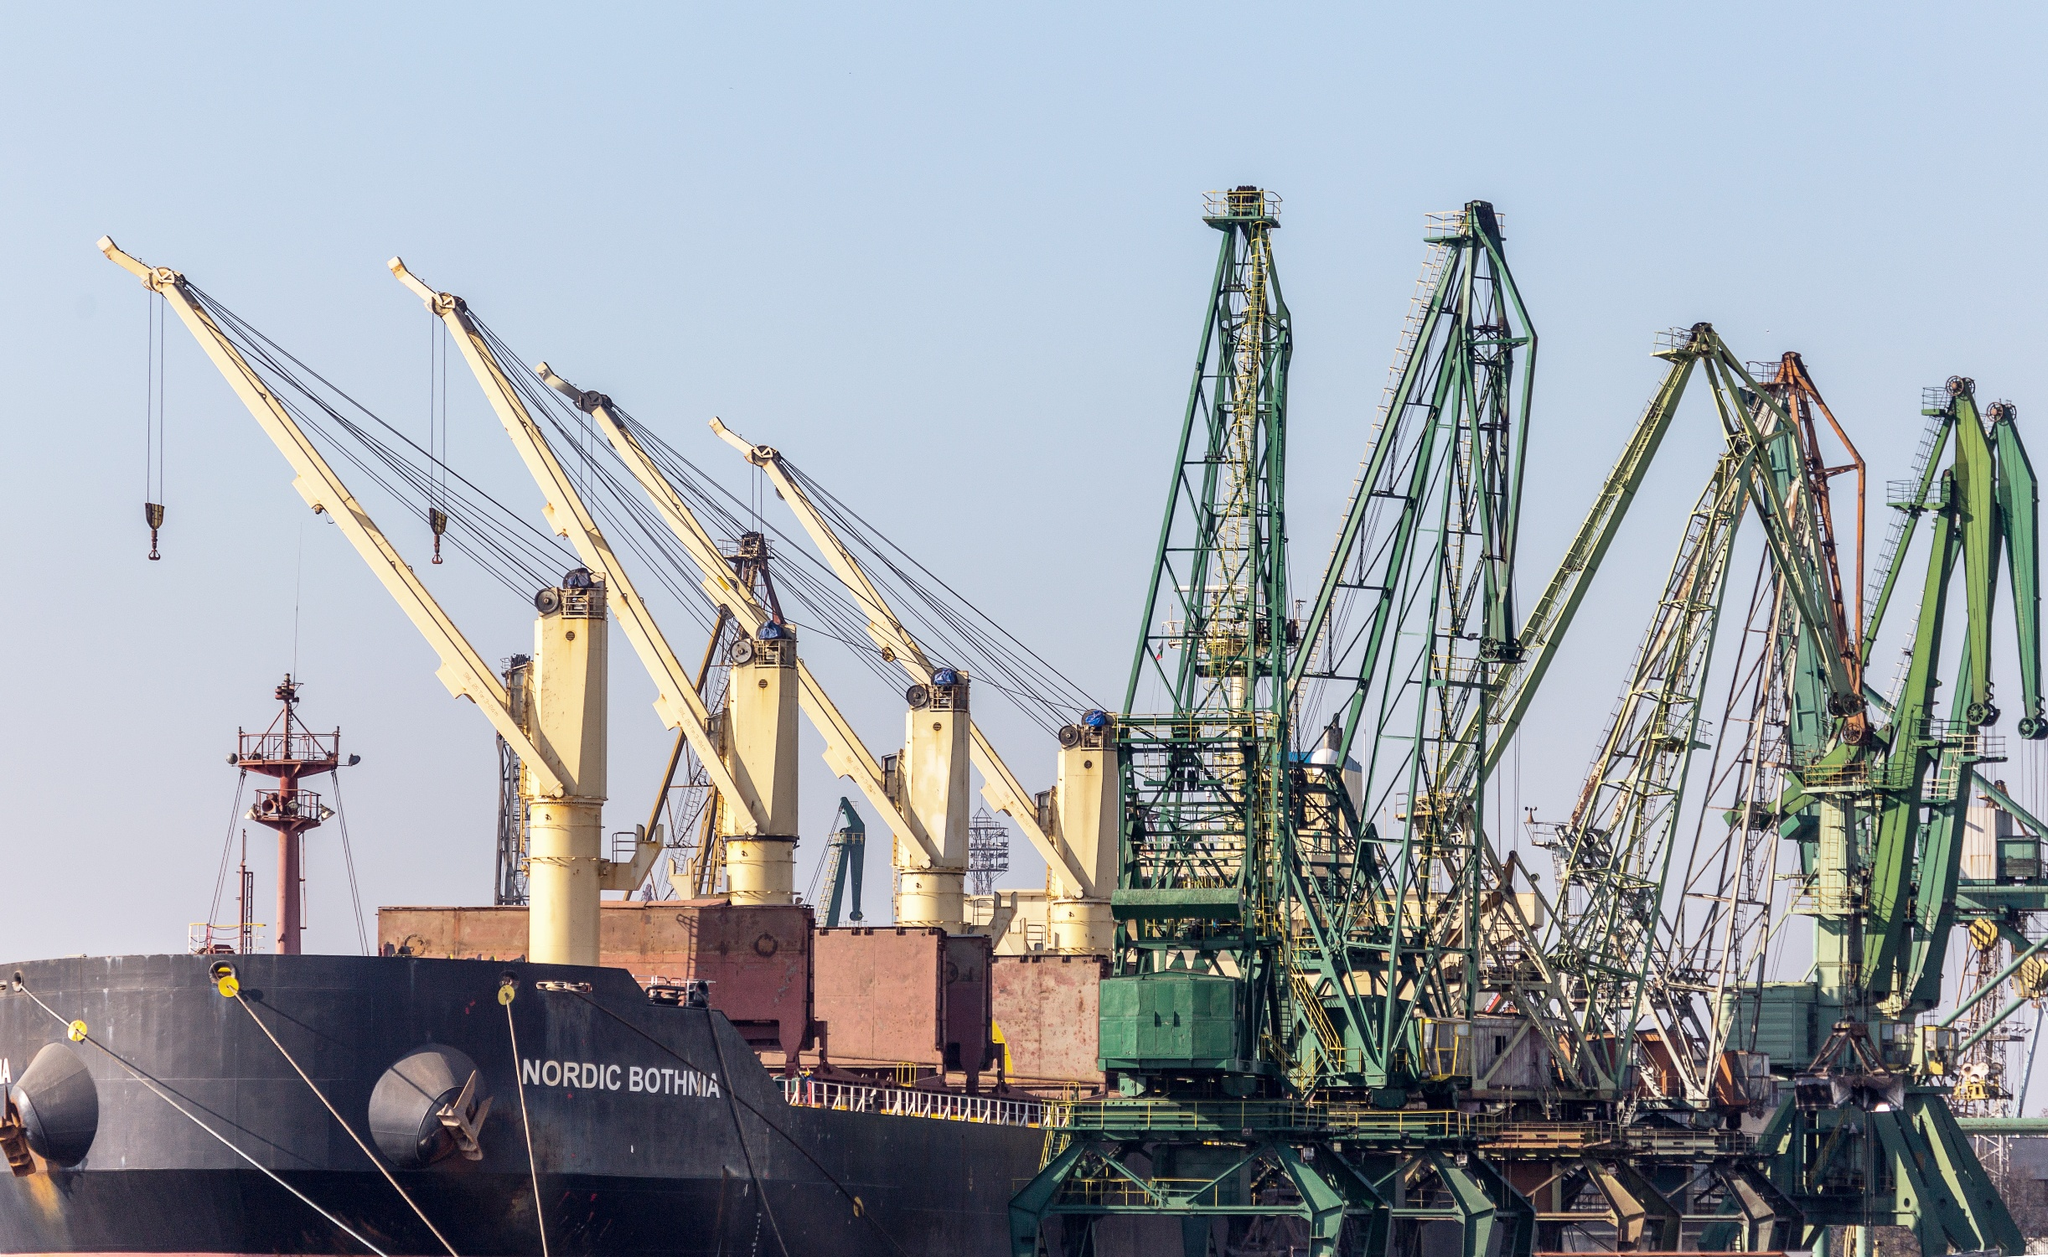Can you tell more about the type of cargo this ship might be carrying? The 'Nordic Bothnia' is likely designed for bulk cargo, which includes items like grains, coal, ores, or steel products. Given its robust structure and heavy-duty cranes, it's equipped to handle large, heavy shipments that require careful handling and significant storage space. 